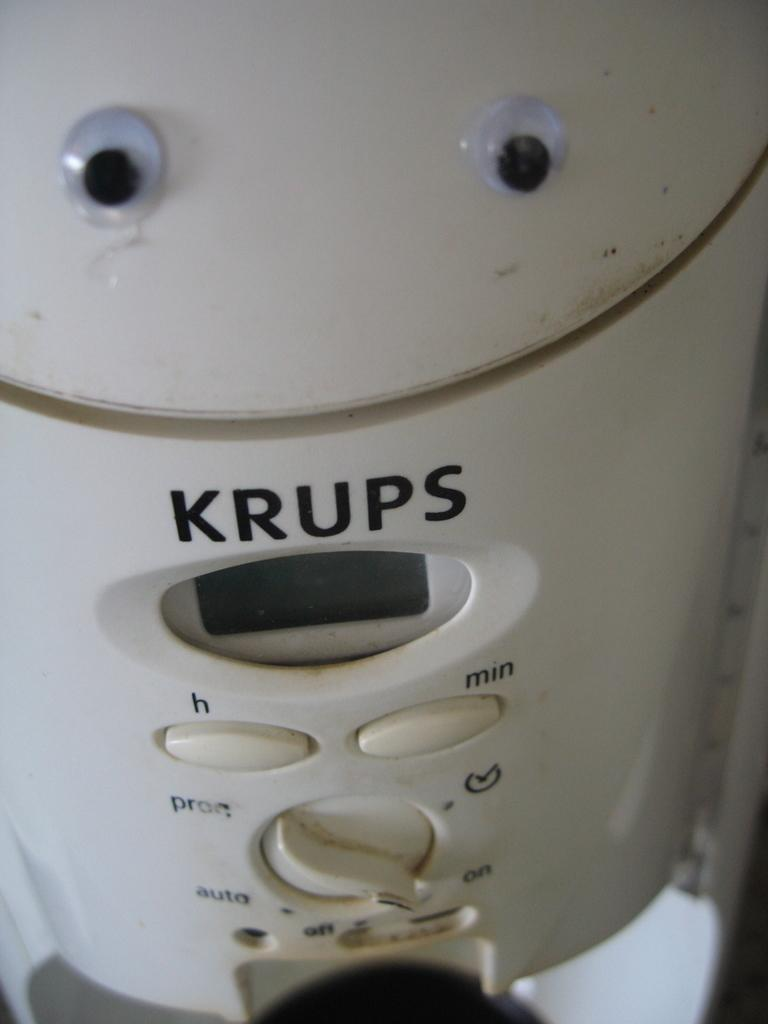<image>
Provide a brief description of the given image. A dirty Krups appliance is in the "on" position. 